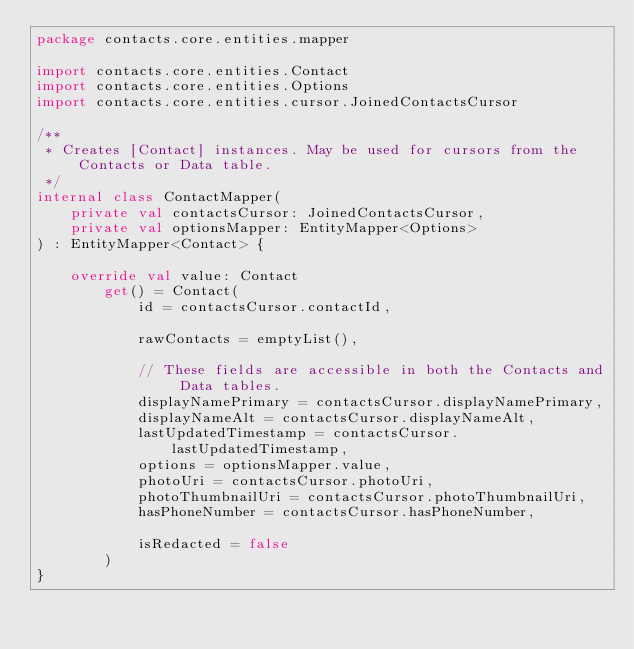Convert code to text. <code><loc_0><loc_0><loc_500><loc_500><_Kotlin_>package contacts.core.entities.mapper

import contacts.core.entities.Contact
import contacts.core.entities.Options
import contacts.core.entities.cursor.JoinedContactsCursor

/**
 * Creates [Contact] instances. May be used for cursors from the Contacts or Data table.
 */
internal class ContactMapper(
    private val contactsCursor: JoinedContactsCursor,
    private val optionsMapper: EntityMapper<Options>
) : EntityMapper<Contact> {

    override val value: Contact
        get() = Contact(
            id = contactsCursor.contactId,

            rawContacts = emptyList(),

            // These fields are accessible in both the Contacts and Data tables.
            displayNamePrimary = contactsCursor.displayNamePrimary,
            displayNameAlt = contactsCursor.displayNameAlt,
            lastUpdatedTimestamp = contactsCursor.lastUpdatedTimestamp,
            options = optionsMapper.value,
            photoUri = contactsCursor.photoUri,
            photoThumbnailUri = contactsCursor.photoThumbnailUri,
            hasPhoneNumber = contactsCursor.hasPhoneNumber,

            isRedacted = false
        )
}</code> 